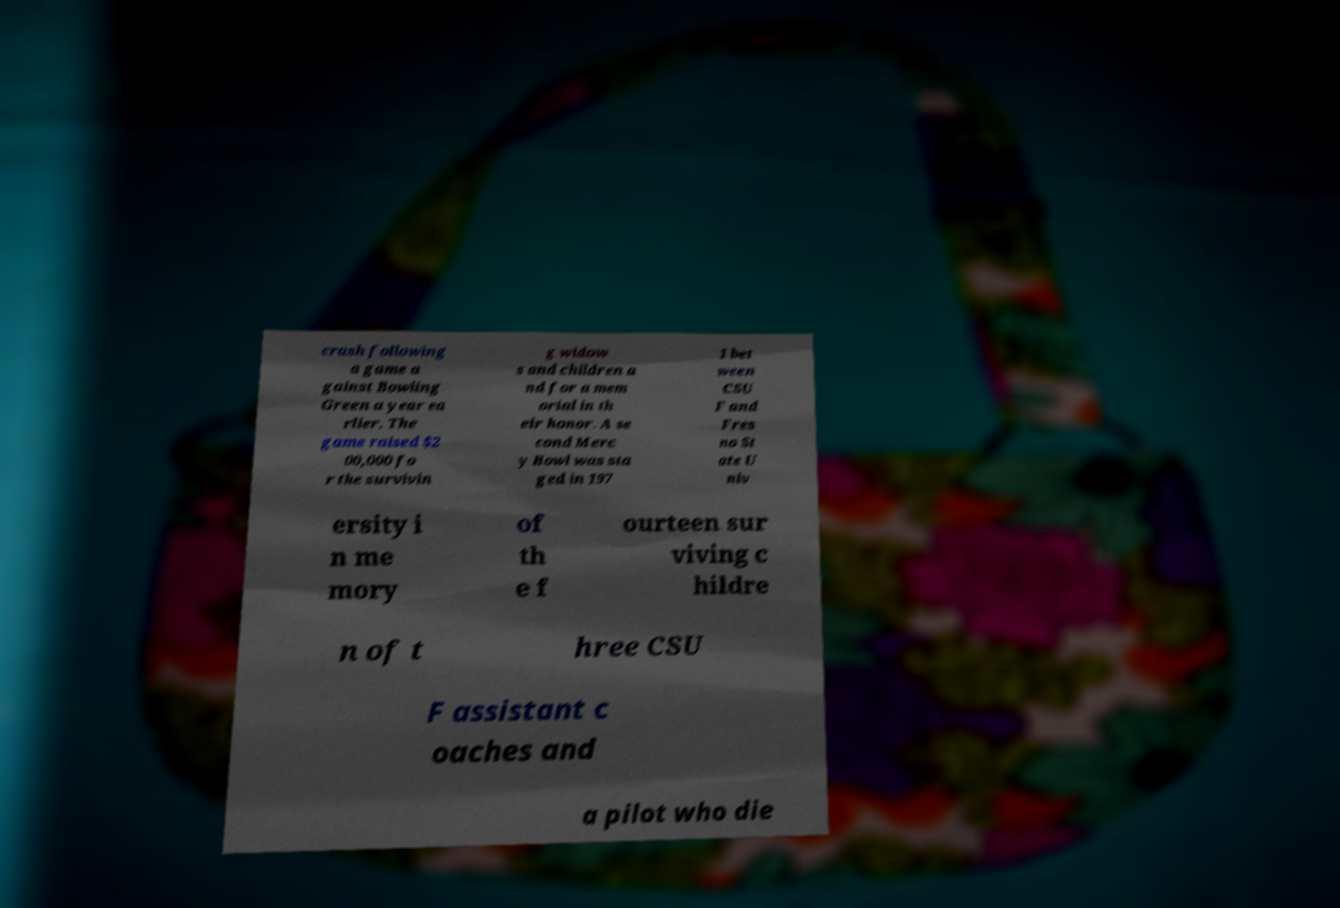Please read and relay the text visible in this image. What does it say? crash following a game a gainst Bowling Green a year ea rlier. The game raised $2 00,000 fo r the survivin g widow s and children a nd for a mem orial in th eir honor. A se cond Merc y Bowl was sta ged in 197 1 bet ween CSU F and Fres no St ate U niv ersity i n me mory of th e f ourteen sur viving c hildre n of t hree CSU F assistant c oaches and a pilot who die 